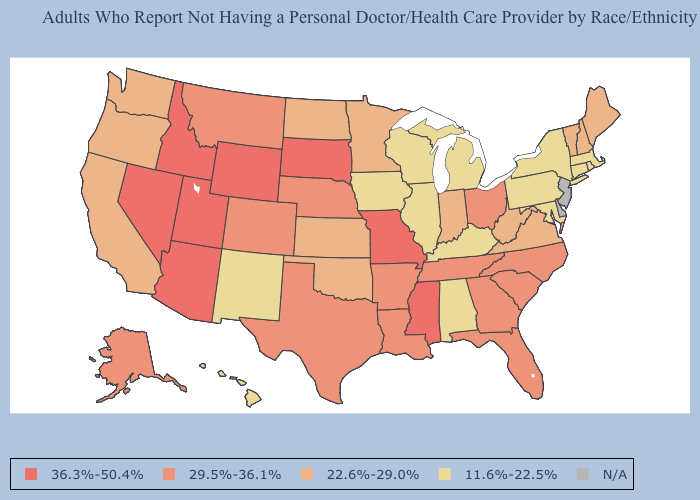What is the highest value in states that border Utah?
Concise answer only. 36.3%-50.4%. Does Nebraska have the lowest value in the USA?
Give a very brief answer. No. Which states have the lowest value in the South?
Write a very short answer. Alabama, Kentucky, Maryland. What is the value of Washington?
Keep it brief. 22.6%-29.0%. Does the first symbol in the legend represent the smallest category?
Concise answer only. No. Name the states that have a value in the range 11.6%-22.5%?
Answer briefly. Alabama, Connecticut, Hawaii, Illinois, Iowa, Kentucky, Maryland, Massachusetts, Michigan, New Mexico, New York, Pennsylvania, Rhode Island, Wisconsin. Does Hawaii have the lowest value in the West?
Write a very short answer. Yes. How many symbols are there in the legend?
Concise answer only. 5. How many symbols are there in the legend?
Keep it brief. 5. Does Massachusetts have the highest value in the USA?
Give a very brief answer. No. What is the value of Massachusetts?
Short answer required. 11.6%-22.5%. Name the states that have a value in the range 11.6%-22.5%?
Write a very short answer. Alabama, Connecticut, Hawaii, Illinois, Iowa, Kentucky, Maryland, Massachusetts, Michigan, New Mexico, New York, Pennsylvania, Rhode Island, Wisconsin. 